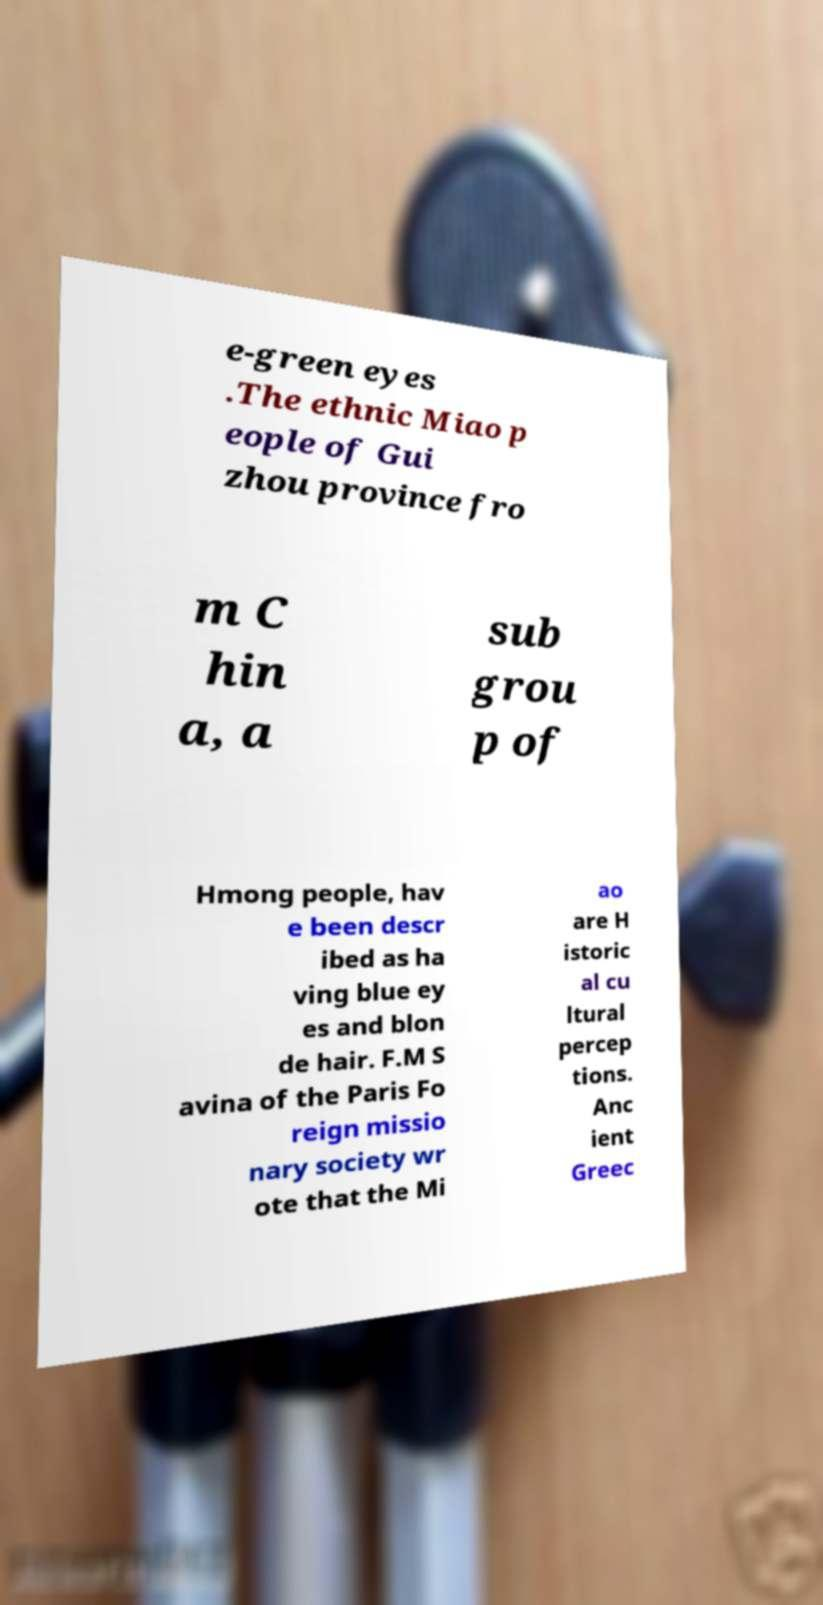Please identify and transcribe the text found in this image. e-green eyes .The ethnic Miao p eople of Gui zhou province fro m C hin a, a sub grou p of Hmong people, hav e been descr ibed as ha ving blue ey es and blon de hair. F.M S avina of the Paris Fo reign missio nary society wr ote that the Mi ao are H istoric al cu ltural percep tions. Anc ient Greec 